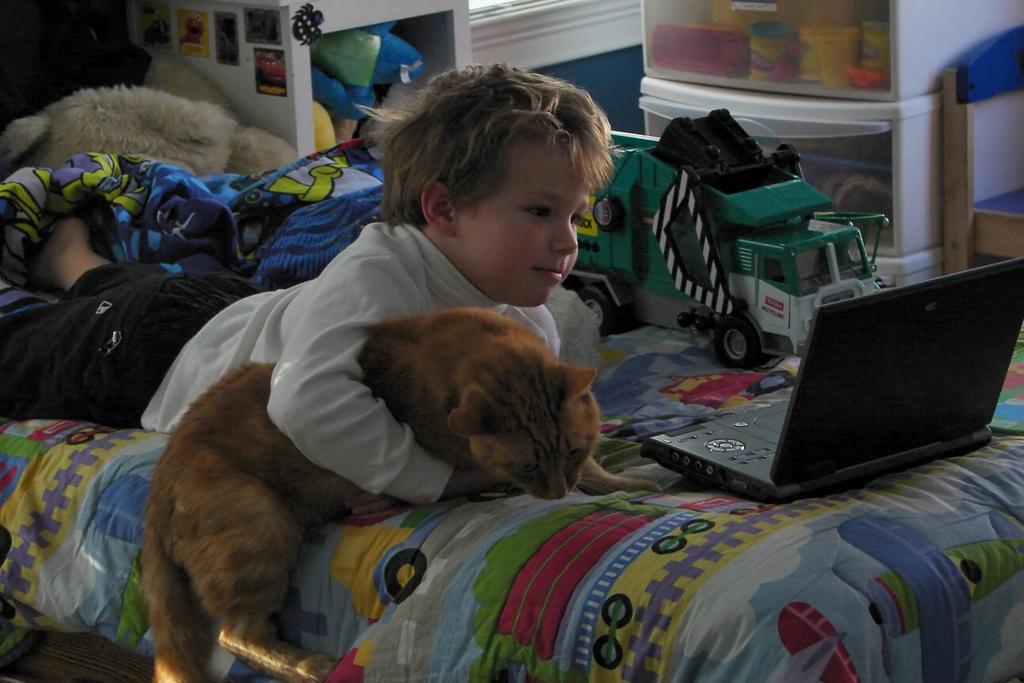Describe this image in one or two sentences. In the center we can see one boy holding cat lying on bed. On bed we can see tab,toy,bed sheet and some more objects. And back we can see table ,chair and few objects around him. 